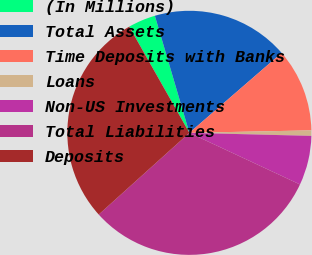Convert chart to OTSL. <chart><loc_0><loc_0><loc_500><loc_500><pie_chart><fcel>(In Millions)<fcel>Total Assets<fcel>Time Deposits with Banks<fcel>Loans<fcel>Non-US Investments<fcel>Total Liabilities<fcel>Deposits<nl><fcel>3.64%<fcel>18.2%<fcel>11.04%<fcel>0.72%<fcel>6.55%<fcel>31.38%<fcel>28.47%<nl></chart> 